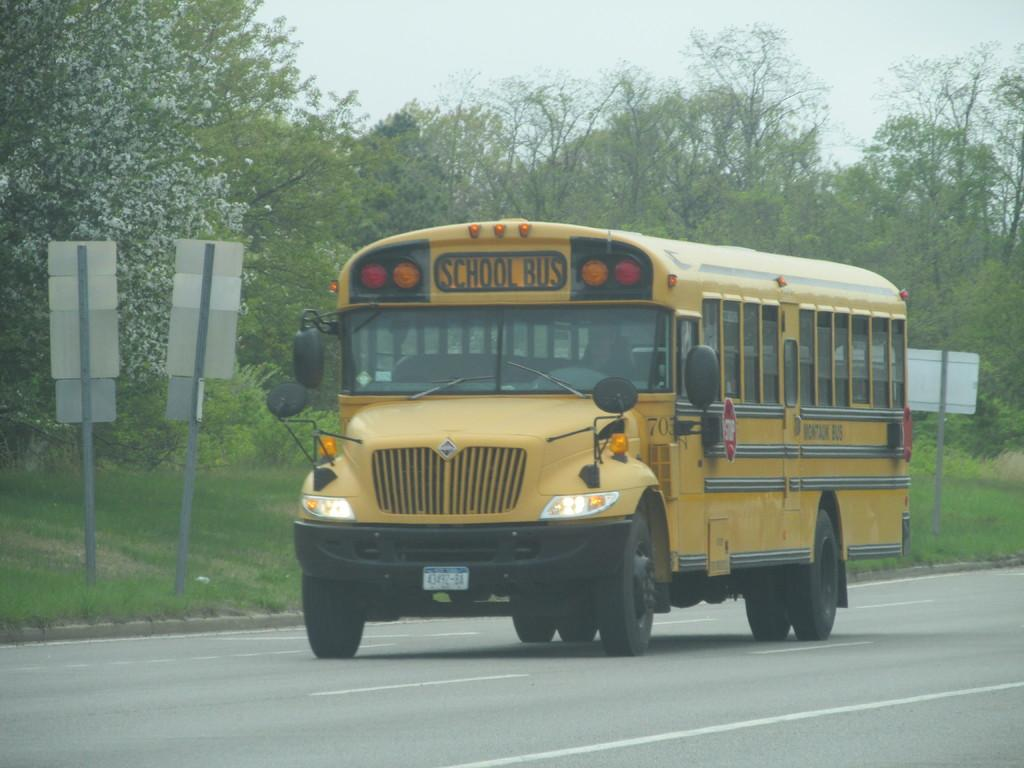What type of vehicle is in the image? There is a school bus in the image. Where is the school bus located? The school bus is on the road. What can be seen attached to poles in the image? There are boards attached to poles in the image. What type of vegetation is visible in the image? There is grass visible in the image, as well as trees with branches and leaves. What part of the natural environment is visible in the image? The sky is visible in the image. How many icicles are hanging from the trees in the image? There are no icicles present in the image, as it features trees with branches and leaves, not ice. What type of discussion is taking place among the trees in the image? There is no discussion taking place among the trees in the image, as trees do not engage in discussions. 